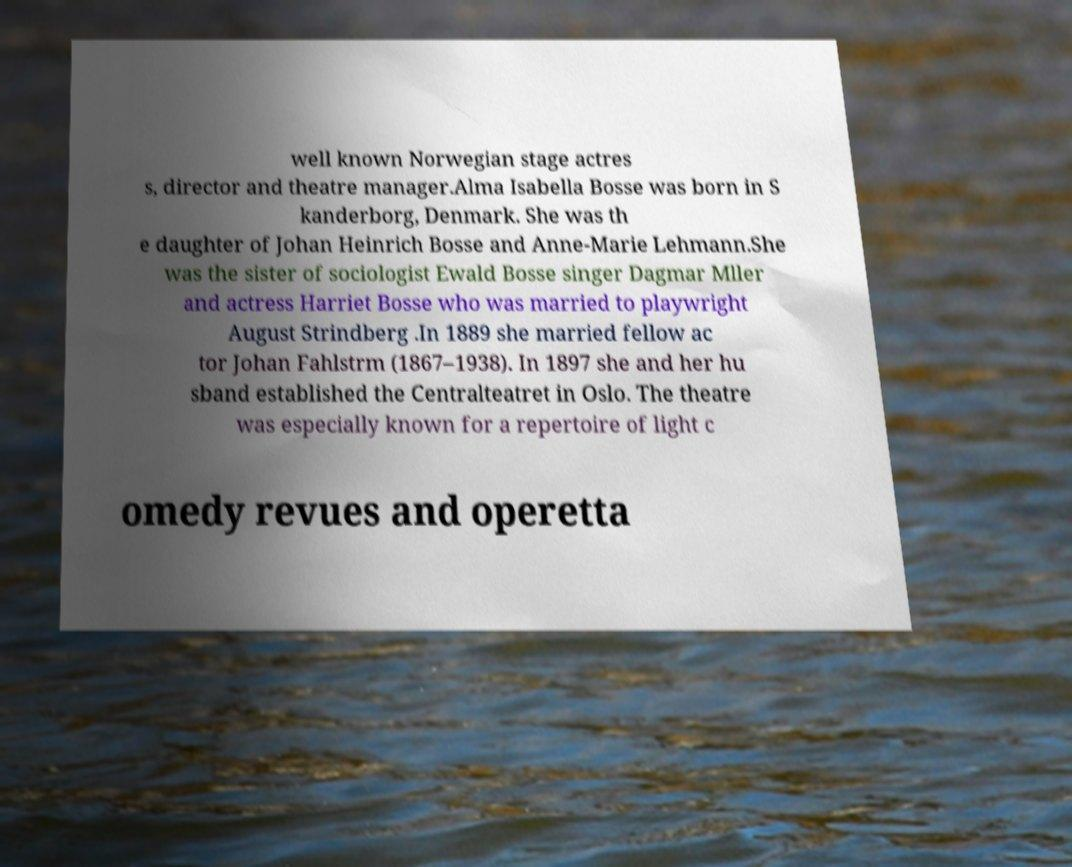Please identify and transcribe the text found in this image. well known Norwegian stage actres s, director and theatre manager.Alma Isabella Bosse was born in S kanderborg, Denmark. She was th e daughter of Johan Heinrich Bosse and Anne-Marie Lehmann.She was the sister of sociologist Ewald Bosse singer Dagmar Mller and actress Harriet Bosse who was married to playwright August Strindberg .In 1889 she married fellow ac tor Johan Fahlstrm (1867–1938). In 1897 she and her hu sband established the Centralteatret in Oslo. The theatre was especially known for a repertoire of light c omedy revues and operetta 